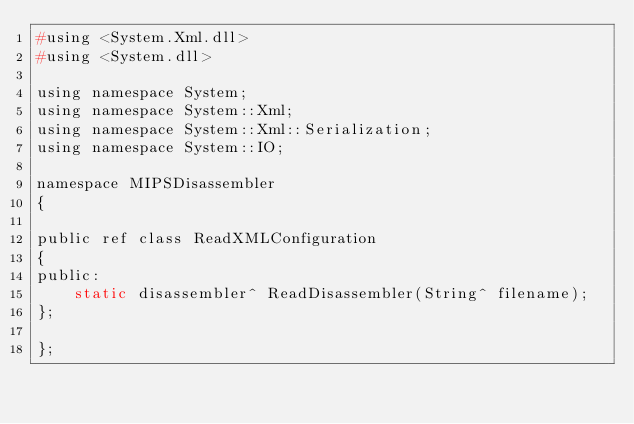<code> <loc_0><loc_0><loc_500><loc_500><_C_>#using <System.Xml.dll>
#using <System.dll>

using namespace System;
using namespace System::Xml;
using namespace System::Xml::Serialization;
using namespace System::IO;

namespace MIPSDisassembler
{

public ref class ReadXMLConfiguration
{
public:
	static disassembler^ ReadDisassembler(String^ filename);
};

};</code> 